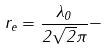<formula> <loc_0><loc_0><loc_500><loc_500>r _ { e } = \frac { \lambda _ { 0 } } { 2 \sqrt { 2 } \pi } -</formula> 